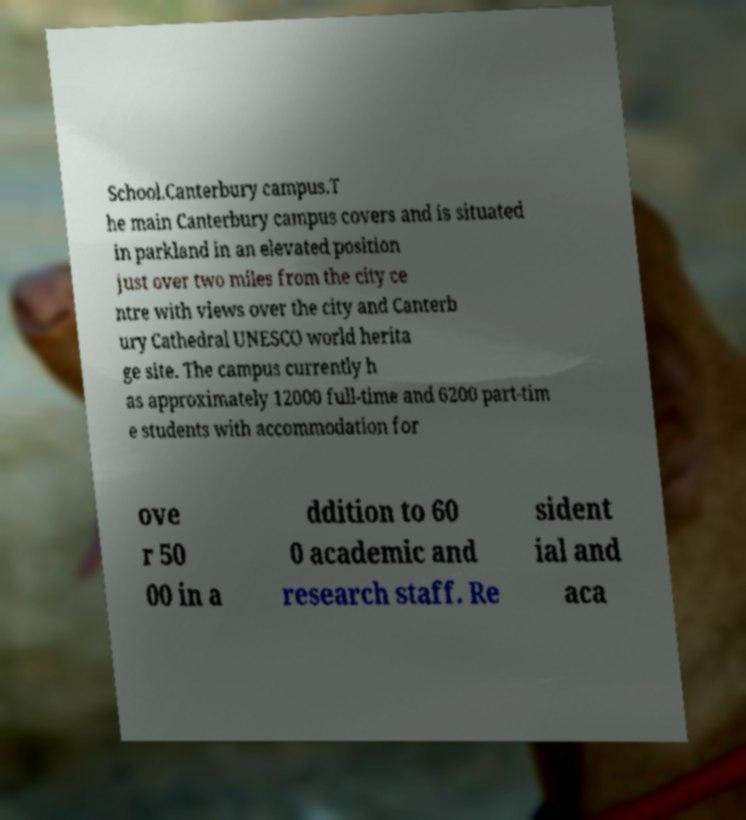Could you assist in decoding the text presented in this image and type it out clearly? School.Canterbury campus.T he main Canterbury campus covers and is situated in parkland in an elevated position just over two miles from the city ce ntre with views over the city and Canterb ury Cathedral UNESCO world herita ge site. The campus currently h as approximately 12000 full-time and 6200 part-tim e students with accommodation for ove r 50 00 in a ddition to 60 0 academic and research staff. Re sident ial and aca 